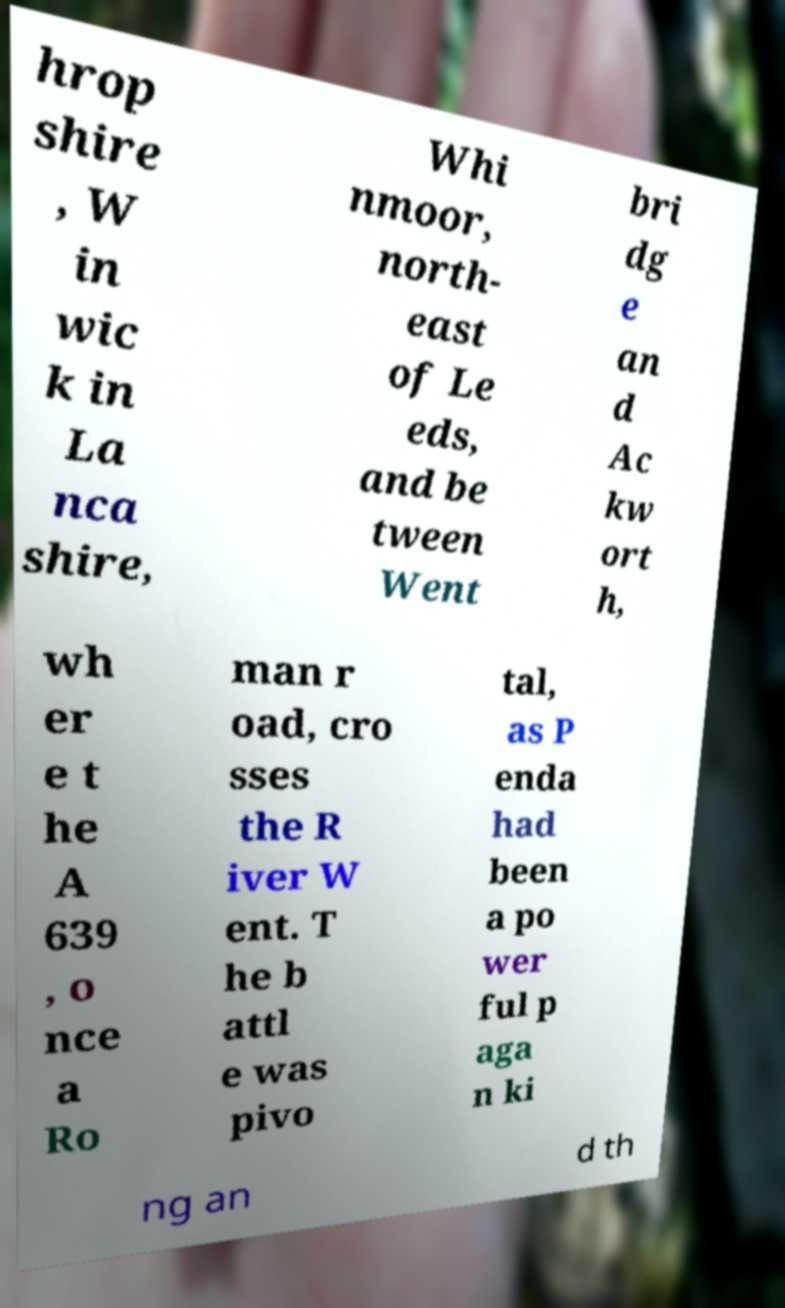Can you read and provide the text displayed in the image?This photo seems to have some interesting text. Can you extract and type it out for me? hrop shire , W in wic k in La nca shire, Whi nmoor, north- east of Le eds, and be tween Went bri dg e an d Ac kw ort h, wh er e t he A 639 , o nce a Ro man r oad, cro sses the R iver W ent. T he b attl e was pivo tal, as P enda had been a po wer ful p aga n ki ng an d th 